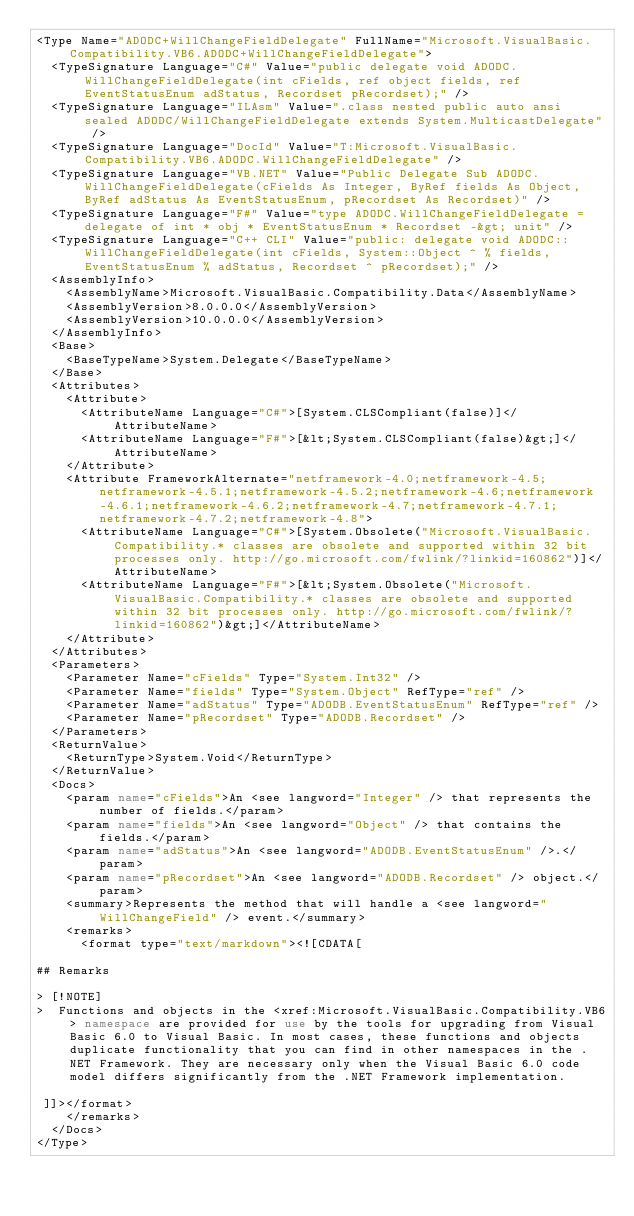<code> <loc_0><loc_0><loc_500><loc_500><_XML_><Type Name="ADODC+WillChangeFieldDelegate" FullName="Microsoft.VisualBasic.Compatibility.VB6.ADODC+WillChangeFieldDelegate">
  <TypeSignature Language="C#" Value="public delegate void ADODC.WillChangeFieldDelegate(int cFields, ref object fields, ref EventStatusEnum adStatus, Recordset pRecordset);" />
  <TypeSignature Language="ILAsm" Value=".class nested public auto ansi sealed ADODC/WillChangeFieldDelegate extends System.MulticastDelegate" />
  <TypeSignature Language="DocId" Value="T:Microsoft.VisualBasic.Compatibility.VB6.ADODC.WillChangeFieldDelegate" />
  <TypeSignature Language="VB.NET" Value="Public Delegate Sub ADODC.WillChangeFieldDelegate(cFields As Integer, ByRef fields As Object, ByRef adStatus As EventStatusEnum, pRecordset As Recordset)" />
  <TypeSignature Language="F#" Value="type ADODC.WillChangeFieldDelegate = delegate of int * obj * EventStatusEnum * Recordset -&gt; unit" />
  <TypeSignature Language="C++ CLI" Value="public: delegate void ADODC::WillChangeFieldDelegate(int cFields, System::Object ^ % fields, EventStatusEnum % adStatus, Recordset ^ pRecordset);" />
  <AssemblyInfo>
    <AssemblyName>Microsoft.VisualBasic.Compatibility.Data</AssemblyName>
    <AssemblyVersion>8.0.0.0</AssemblyVersion>
    <AssemblyVersion>10.0.0.0</AssemblyVersion>
  </AssemblyInfo>
  <Base>
    <BaseTypeName>System.Delegate</BaseTypeName>
  </Base>
  <Attributes>
    <Attribute>
      <AttributeName Language="C#">[System.CLSCompliant(false)]</AttributeName>
      <AttributeName Language="F#">[&lt;System.CLSCompliant(false)&gt;]</AttributeName>
    </Attribute>
    <Attribute FrameworkAlternate="netframework-4.0;netframework-4.5;netframework-4.5.1;netframework-4.5.2;netframework-4.6;netframework-4.6.1;netframework-4.6.2;netframework-4.7;netframework-4.7.1;netframework-4.7.2;netframework-4.8">
      <AttributeName Language="C#">[System.Obsolete("Microsoft.VisualBasic.Compatibility.* classes are obsolete and supported within 32 bit processes only. http://go.microsoft.com/fwlink/?linkid=160862")]</AttributeName>
      <AttributeName Language="F#">[&lt;System.Obsolete("Microsoft.VisualBasic.Compatibility.* classes are obsolete and supported within 32 bit processes only. http://go.microsoft.com/fwlink/?linkid=160862")&gt;]</AttributeName>
    </Attribute>
  </Attributes>
  <Parameters>
    <Parameter Name="cFields" Type="System.Int32" />
    <Parameter Name="fields" Type="System.Object" RefType="ref" />
    <Parameter Name="adStatus" Type="ADODB.EventStatusEnum" RefType="ref" />
    <Parameter Name="pRecordset" Type="ADODB.Recordset" />
  </Parameters>
  <ReturnValue>
    <ReturnType>System.Void</ReturnType>
  </ReturnValue>
  <Docs>
    <param name="cFields">An <see langword="Integer" /> that represents the number of fields.</param>
    <param name="fields">An <see langword="Object" /> that contains the fields.</param>
    <param name="adStatus">An <see langword="ADODB.EventStatusEnum" />.</param>
    <param name="pRecordset">An <see langword="ADODB.Recordset" /> object.</param>
    <summary>Represents the method that will handle a <see langword="WillChangeField" /> event.</summary>
    <remarks>
      <format type="text/markdown"><![CDATA[  
  
## Remarks  
  
> [!NOTE]
>  Functions and objects in the <xref:Microsoft.VisualBasic.Compatibility.VB6> namespace are provided for use by the tools for upgrading from Visual Basic 6.0 to Visual Basic. In most cases, these functions and objects duplicate functionality that you can find in other namespaces in the .NET Framework. They are necessary only when the Visual Basic 6.0 code model differs significantly from the .NET Framework implementation.  
  
 ]]></format>
    </remarks>
  </Docs>
</Type>
</code> 